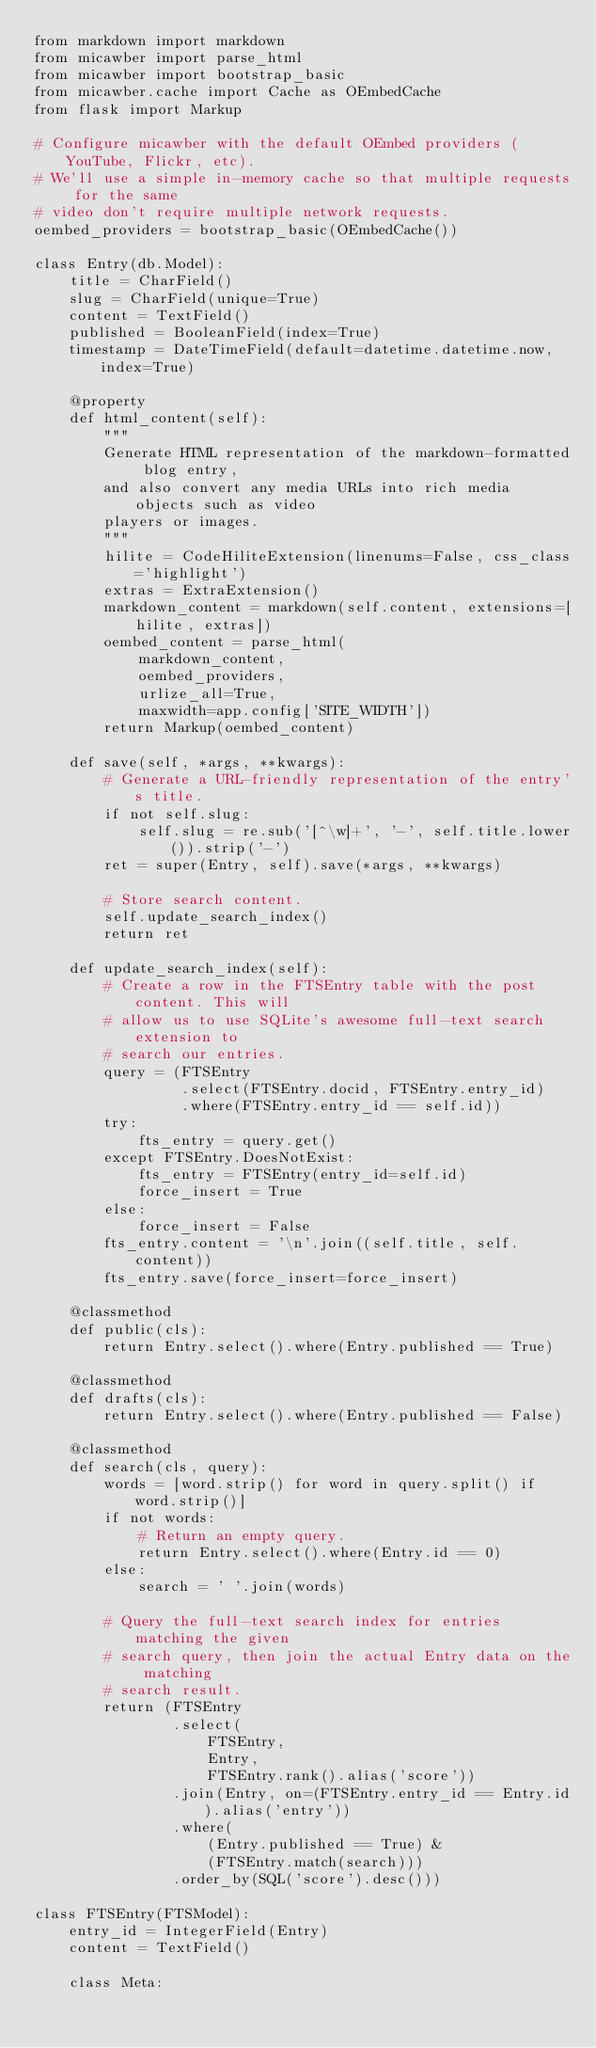Convert code to text. <code><loc_0><loc_0><loc_500><loc_500><_Python_>from markdown import markdown
from micawber import parse_html
from micawber import bootstrap_basic
from micawber.cache import Cache as OEmbedCache
from flask import Markup

# Configure micawber with the default OEmbed providers (YouTube, Flickr, etc).
# We'll use a simple in-memory cache so that multiple requests for the same
# video don't require multiple network requests.
oembed_providers = bootstrap_basic(OEmbedCache())

class Entry(db.Model):
    title = CharField()
    slug = CharField(unique=True)
    content = TextField()
    published = BooleanField(index=True)
    timestamp = DateTimeField(default=datetime.datetime.now, index=True)

    @property
    def html_content(self):
        """
        Generate HTML representation of the markdown-formatted blog entry,
        and also convert any media URLs into rich media objects such as video
        players or images.
        """
        hilite = CodeHiliteExtension(linenums=False, css_class='highlight')
        extras = ExtraExtension()
        markdown_content = markdown(self.content, extensions=[hilite, extras])
        oembed_content = parse_html(
            markdown_content,
            oembed_providers,
            urlize_all=True,
            maxwidth=app.config['SITE_WIDTH'])
        return Markup(oembed_content)

    def save(self, *args, **kwargs):
        # Generate a URL-friendly representation of the entry's title.
        if not self.slug:
            self.slug = re.sub('[^\w]+', '-', self.title.lower()).strip('-')
        ret = super(Entry, self).save(*args, **kwargs)

        # Store search content.
        self.update_search_index()
        return ret

    def update_search_index(self):
        # Create a row in the FTSEntry table with the post content. This will
        # allow us to use SQLite's awesome full-text search extension to
        # search our entries.
        query = (FTSEntry
                 .select(FTSEntry.docid, FTSEntry.entry_id)
                 .where(FTSEntry.entry_id == self.id))
        try:
            fts_entry = query.get()
        except FTSEntry.DoesNotExist:
            fts_entry = FTSEntry(entry_id=self.id)
            force_insert = True
        else:
            force_insert = False
        fts_entry.content = '\n'.join((self.title, self.content))
        fts_entry.save(force_insert=force_insert)

    @classmethod
    def public(cls):
        return Entry.select().where(Entry.published == True)

    @classmethod
    def drafts(cls):
        return Entry.select().where(Entry.published == False)

    @classmethod
    def search(cls, query):
        words = [word.strip() for word in query.split() if word.strip()]
        if not words:
            # Return an empty query.
            return Entry.select().where(Entry.id == 0)
        else:
            search = ' '.join(words)

        # Query the full-text search index for entries matching the given
        # search query, then join the actual Entry data on the matching
        # search result.
        return (FTSEntry
                .select(
                    FTSEntry,
                    Entry,
                    FTSEntry.rank().alias('score'))
                .join(Entry, on=(FTSEntry.entry_id == Entry.id).alias('entry'))
                .where(
                    (Entry.published == True) &
                    (FTSEntry.match(search)))
                .order_by(SQL('score').desc()))

class FTSEntry(FTSModel):
    entry_id = IntegerField(Entry)
    content = TextField()

    class Meta:</code> 